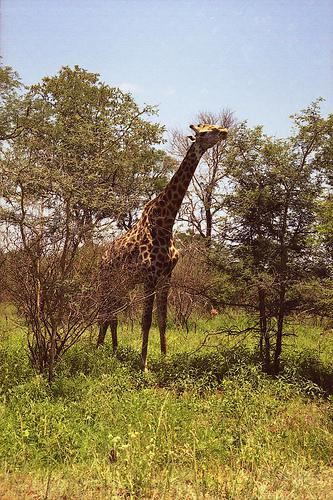Question: how many giraffes are there?
Choices:
A. 2.
B. 3.
C. 5.
D. 1.
Answer with the letter. Answer: D Question: what is the animal?
Choices:
A. A dog.
B. A giraffe.
C. A bear.
D. A moose.
Answer with the letter. Answer: B Question: where is the land of origin?
Choices:
A. Africa.
B. Italy.
C. Germany.
D. Ireland.
Answer with the letter. Answer: A Question: what is a mammal?
Choices:
A. This giraffe.
B. An elephant.
C. A bear.
D. A rhino.
Answer with the letter. Answer: A 